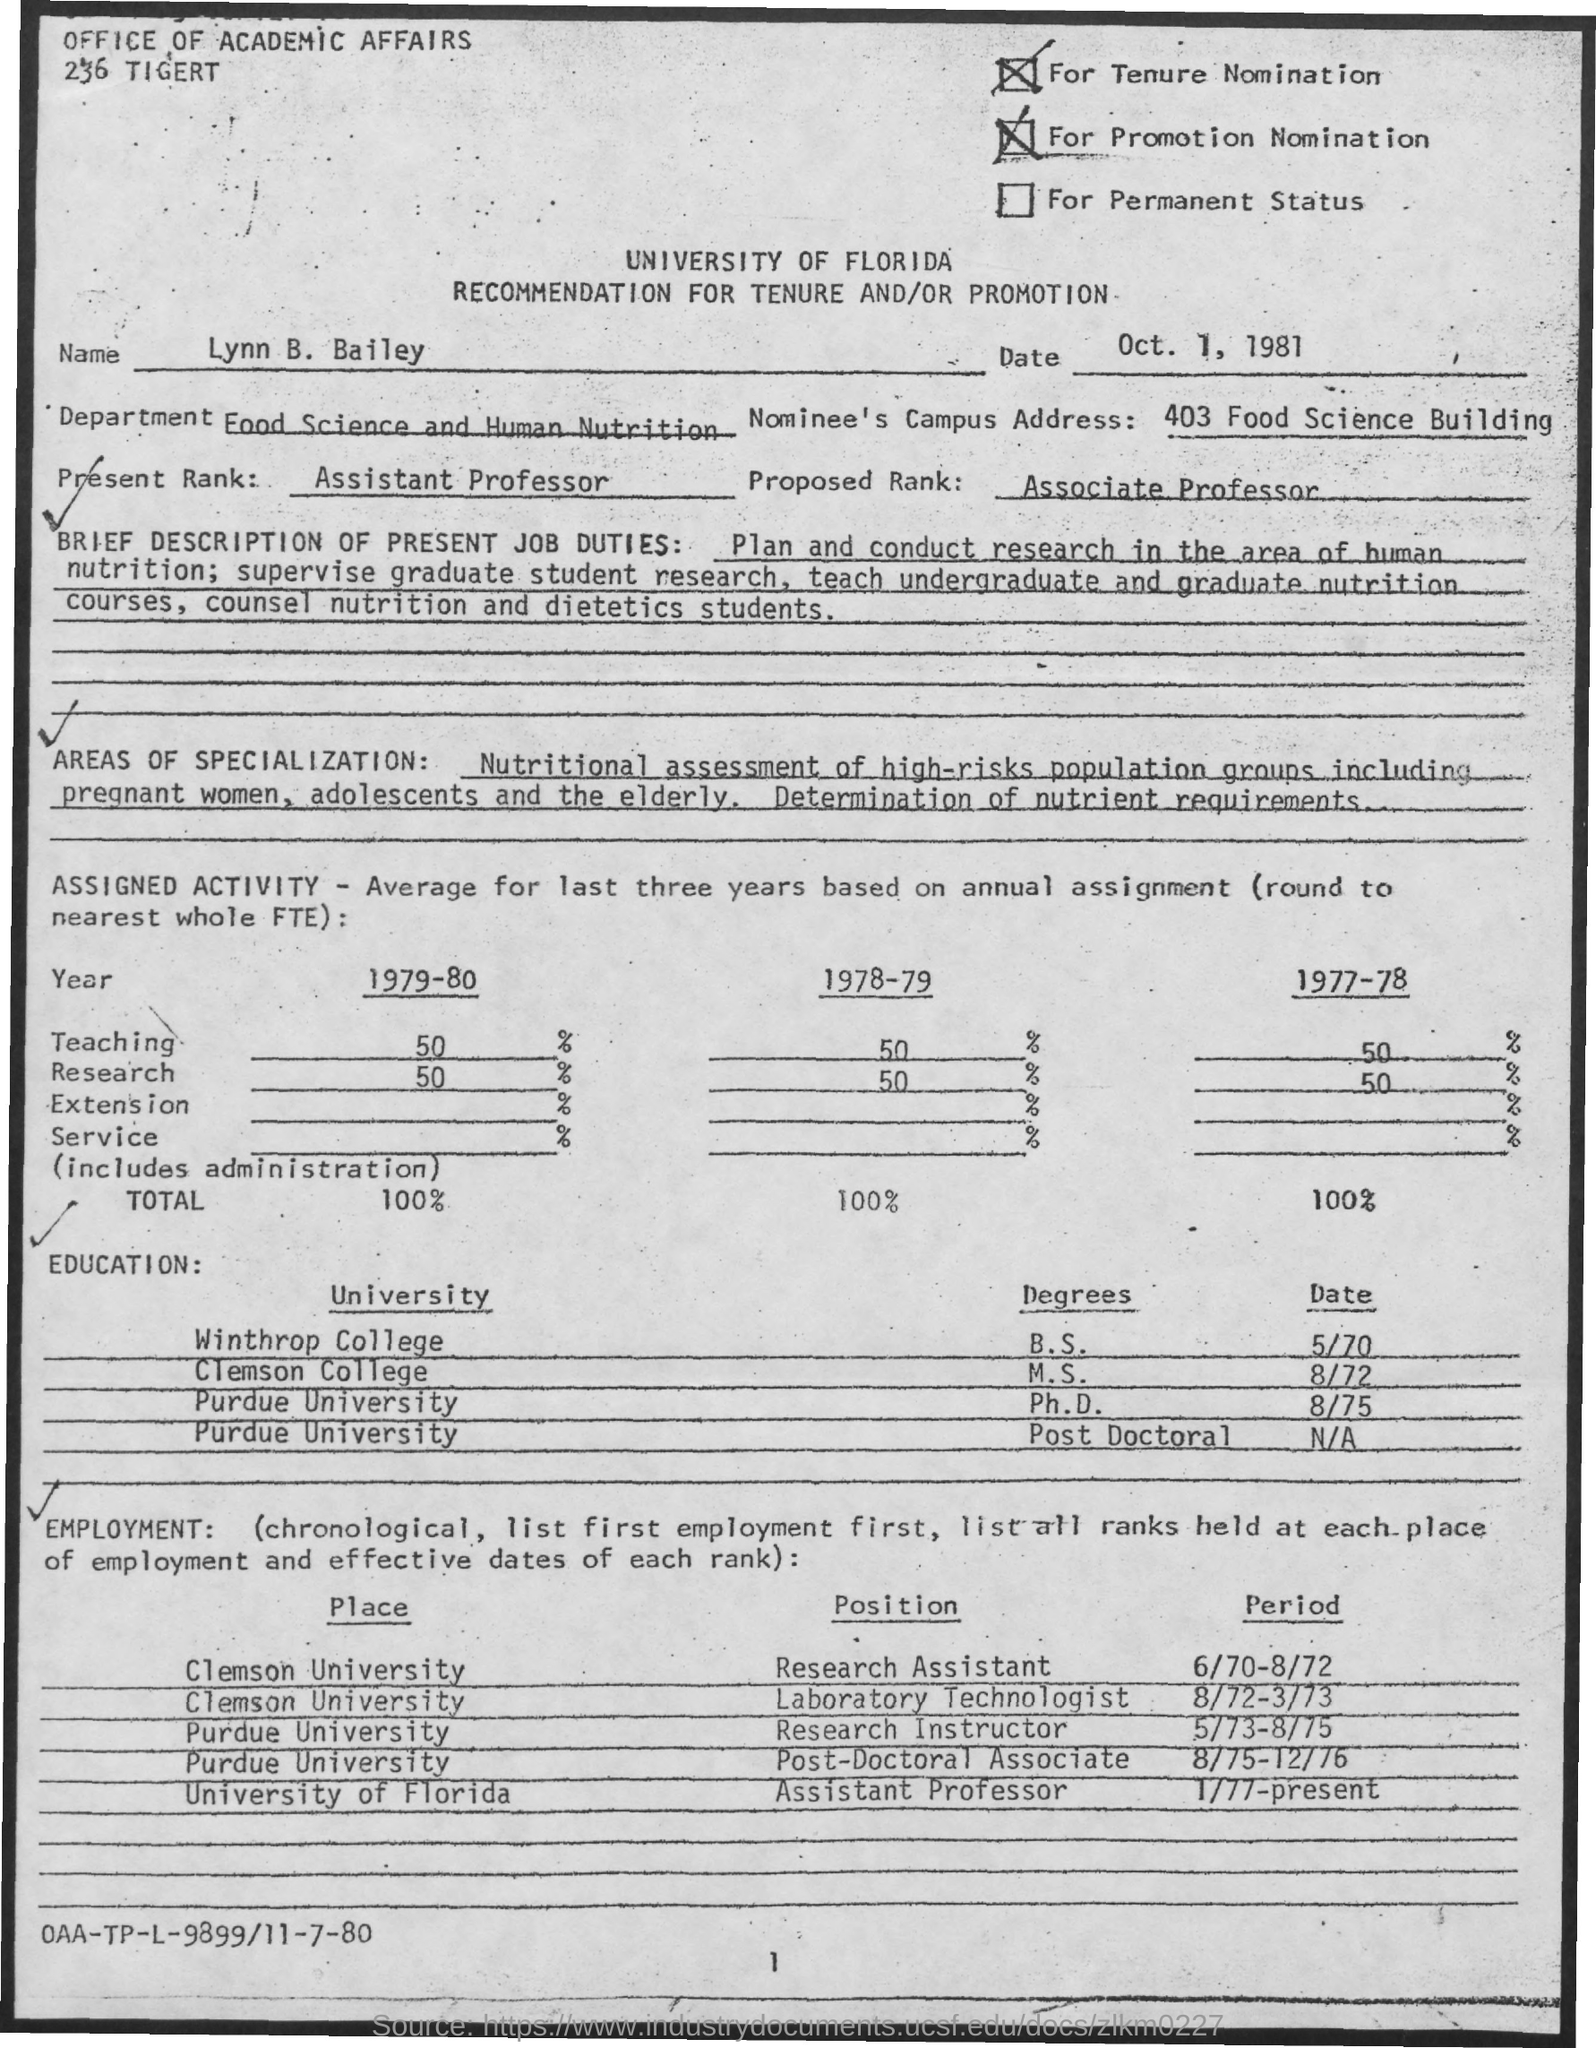In which department , Lynn B. Bailey works?
Ensure brevity in your answer.  Food science and human nutrition. What is the present rank of Lynn B. Bailey?
Make the answer very short. Assistant Professor. What is the Nominee's Campus Address given in the document?
Your answer should be compact. 403 Food Science Building. In which University, Lynn B. Bailey completed Ph.D.?
Provide a short and direct response. Purdue university. What is the issued date of this document?
Your answer should be compact. Oct. 1, 1981. During which period, Lynn B. Bailey worked as Research Assistant at Clemson University?
Make the answer very short. 6/70-8/72. During which period, Lynn B. Bailey worked as a Post-Doctoral Associate at Purdue University?
Your response must be concise. 8/75-12/76. 